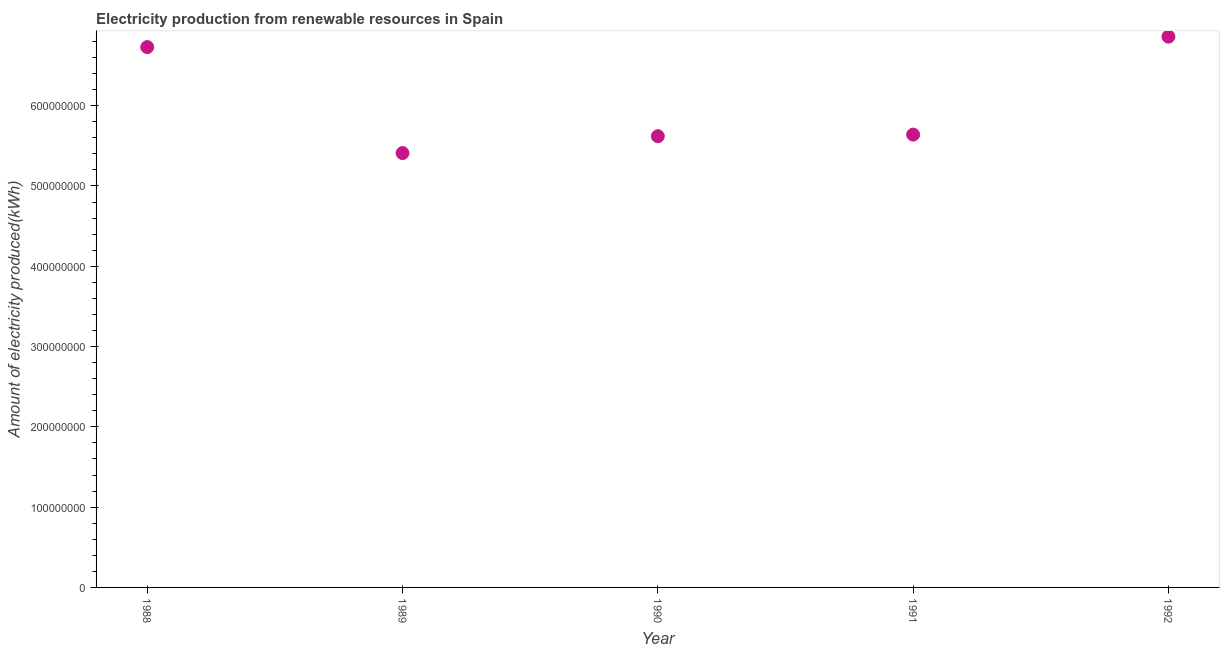What is the amount of electricity produced in 1988?
Provide a short and direct response. 6.73e+08. Across all years, what is the maximum amount of electricity produced?
Your response must be concise. 6.86e+08. Across all years, what is the minimum amount of electricity produced?
Offer a very short reply. 5.41e+08. What is the sum of the amount of electricity produced?
Ensure brevity in your answer.  3.03e+09. What is the difference between the amount of electricity produced in 1991 and 1992?
Your answer should be very brief. -1.22e+08. What is the average amount of electricity produced per year?
Your answer should be compact. 6.05e+08. What is the median amount of electricity produced?
Make the answer very short. 5.64e+08. In how many years, is the amount of electricity produced greater than 140000000 kWh?
Offer a very short reply. 5. Do a majority of the years between 1988 and 1989 (inclusive) have amount of electricity produced greater than 520000000 kWh?
Provide a short and direct response. Yes. What is the ratio of the amount of electricity produced in 1990 to that in 1991?
Keep it short and to the point. 1. Is the amount of electricity produced in 1989 less than that in 1990?
Ensure brevity in your answer.  Yes. What is the difference between the highest and the second highest amount of electricity produced?
Offer a very short reply. 1.30e+07. What is the difference between the highest and the lowest amount of electricity produced?
Your answer should be very brief. 1.45e+08. In how many years, is the amount of electricity produced greater than the average amount of electricity produced taken over all years?
Provide a succinct answer. 2. How many dotlines are there?
Ensure brevity in your answer.  1. How many years are there in the graph?
Your answer should be very brief. 5. What is the difference between two consecutive major ticks on the Y-axis?
Your response must be concise. 1.00e+08. Does the graph contain any zero values?
Offer a very short reply. No. Does the graph contain grids?
Your answer should be very brief. No. What is the title of the graph?
Your response must be concise. Electricity production from renewable resources in Spain. What is the label or title of the X-axis?
Provide a succinct answer. Year. What is the label or title of the Y-axis?
Provide a succinct answer. Amount of electricity produced(kWh). What is the Amount of electricity produced(kWh) in 1988?
Keep it short and to the point. 6.73e+08. What is the Amount of electricity produced(kWh) in 1989?
Your answer should be very brief. 5.41e+08. What is the Amount of electricity produced(kWh) in 1990?
Offer a terse response. 5.62e+08. What is the Amount of electricity produced(kWh) in 1991?
Your response must be concise. 5.64e+08. What is the Amount of electricity produced(kWh) in 1992?
Offer a very short reply. 6.86e+08. What is the difference between the Amount of electricity produced(kWh) in 1988 and 1989?
Provide a succinct answer. 1.32e+08. What is the difference between the Amount of electricity produced(kWh) in 1988 and 1990?
Offer a terse response. 1.11e+08. What is the difference between the Amount of electricity produced(kWh) in 1988 and 1991?
Give a very brief answer. 1.09e+08. What is the difference between the Amount of electricity produced(kWh) in 1988 and 1992?
Provide a succinct answer. -1.30e+07. What is the difference between the Amount of electricity produced(kWh) in 1989 and 1990?
Provide a short and direct response. -2.10e+07. What is the difference between the Amount of electricity produced(kWh) in 1989 and 1991?
Give a very brief answer. -2.30e+07. What is the difference between the Amount of electricity produced(kWh) in 1989 and 1992?
Provide a short and direct response. -1.45e+08. What is the difference between the Amount of electricity produced(kWh) in 1990 and 1992?
Keep it short and to the point. -1.24e+08. What is the difference between the Amount of electricity produced(kWh) in 1991 and 1992?
Ensure brevity in your answer.  -1.22e+08. What is the ratio of the Amount of electricity produced(kWh) in 1988 to that in 1989?
Offer a very short reply. 1.24. What is the ratio of the Amount of electricity produced(kWh) in 1988 to that in 1990?
Make the answer very short. 1.2. What is the ratio of the Amount of electricity produced(kWh) in 1988 to that in 1991?
Your response must be concise. 1.19. What is the ratio of the Amount of electricity produced(kWh) in 1989 to that in 1990?
Provide a succinct answer. 0.96. What is the ratio of the Amount of electricity produced(kWh) in 1989 to that in 1992?
Keep it short and to the point. 0.79. What is the ratio of the Amount of electricity produced(kWh) in 1990 to that in 1991?
Your answer should be very brief. 1. What is the ratio of the Amount of electricity produced(kWh) in 1990 to that in 1992?
Ensure brevity in your answer.  0.82. What is the ratio of the Amount of electricity produced(kWh) in 1991 to that in 1992?
Provide a short and direct response. 0.82. 